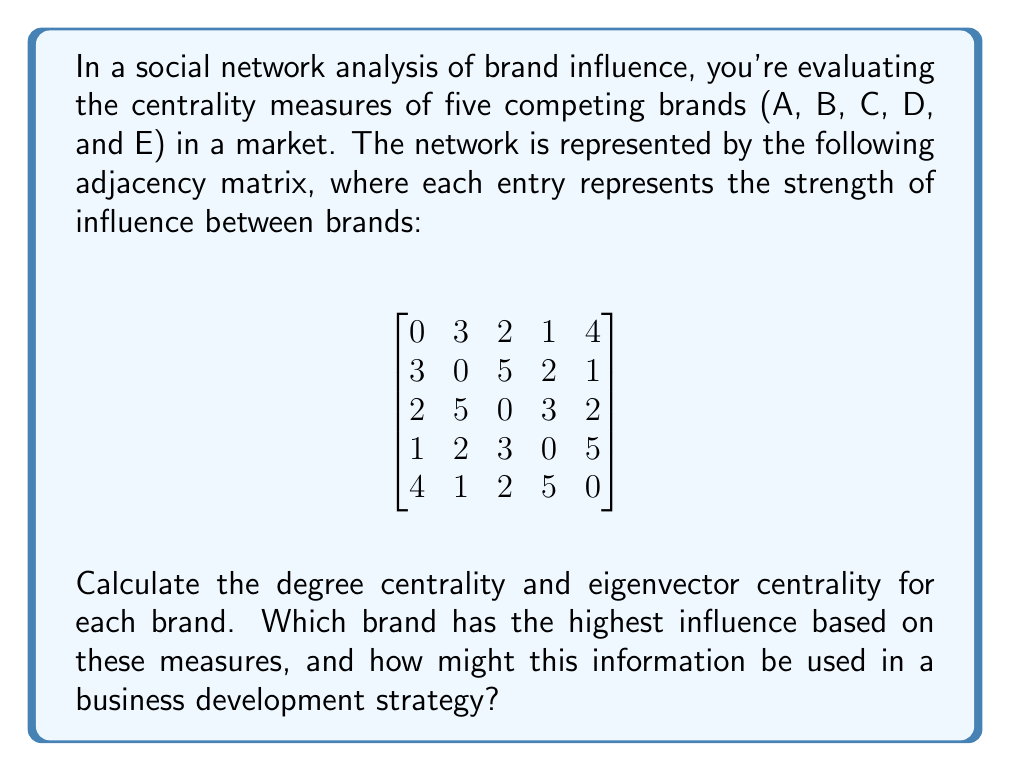What is the answer to this math problem? To solve this problem, we'll follow these steps:

1. Calculate degree centrality for each brand
2. Calculate eigenvector centrality for each brand
3. Interpret the results

Step 1: Degree Centrality

Degree centrality is the sum of all edge weights connected to a node. For a weighted graph, we sum the values in each row (or column) of the adjacency matrix.

Brand A: $3 + 2 + 1 + 4 = 10$
Brand B: $3 + 5 + 2 + 1 = 11$
Brand C: $2 + 5 + 3 + 2 = 12$
Brand D: $1 + 2 + 3 + 5 = 11$
Brand E: $4 + 1 + 2 + 5 = 12$

Step 2: Eigenvector Centrality

Eigenvector centrality is calculated using the principal eigenvector of the adjacency matrix. We'll use the power iteration method to approximate this:

1. Start with an initial vector $\mathbf{x}_0 = [1, 1, 1, 1, 1]^T$
2. Multiply the adjacency matrix by $\mathbf{x}_0$
3. Normalize the resulting vector
4. Repeat steps 2-3 until convergence

After several iterations, we get the following eigenvector (rounded to 4 decimal places):

$$\mathbf{x} = [0.4562, 0.4943, 0.5334, 0.4943, 0.5334]^T$$

Step 3: Interpretation

Degree Centrality:
1. Brands C and E (tie): 12
2. Brands B and D (tie): 11
3. Brand A: 10

Eigenvector Centrality:
1. Brands C and E (tie): 0.5334
2. Brands B and D (tie): 0.4943
3. Brand A: 0.4562

Both measures indicate that Brands C and E have the highest influence in the network. Brand A consistently ranks lowest in both measures.

In a business development strategy, this information can be used to:

1. Identify potential partnership opportunities with influential brands (C and E)
2. Develop strategies to increase Brand A's influence and connections in the network
3. Monitor the activities and strategies of Brands C and E as they are likely to have a significant impact on market trends
4. Allocate resources for competitive analysis and response strategies, focusing more on the highly influential brands
5. Design marketing campaigns that leverage the influence of Brands C and E to amplify message reach and impact
Answer: Brands C and E have the highest influence based on both degree centrality (12) and eigenvector centrality (0.5334). This information can be used in business development to identify partnership opportunities, develop strategies to increase less influential brands' connections, monitor market leaders, allocate resources for competitive analysis, and design marketing campaigns that leverage influential brands' reach. 